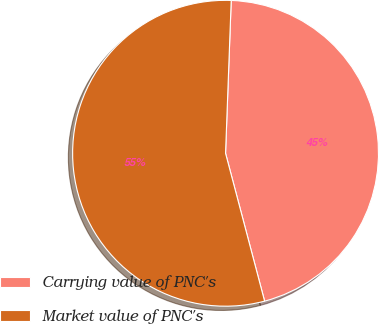Convert chart. <chart><loc_0><loc_0><loc_500><loc_500><pie_chart><fcel>Carrying value of PNC's<fcel>Market value of PNC's<nl><fcel>45.3%<fcel>54.7%<nl></chart> 